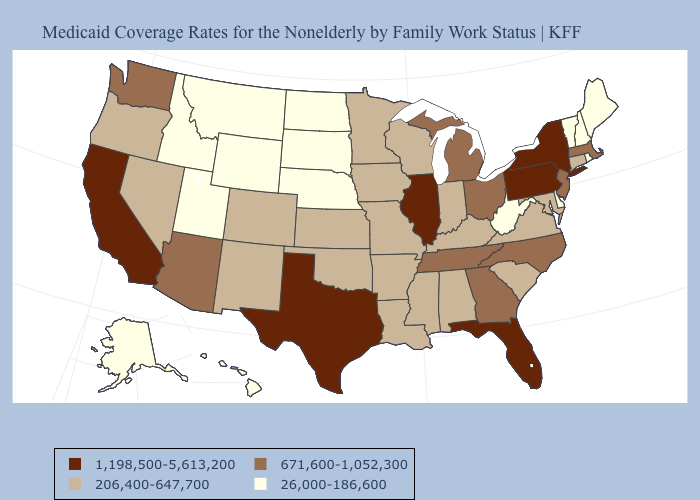What is the highest value in the USA?
Be succinct. 1,198,500-5,613,200. Is the legend a continuous bar?
Be succinct. No. Does Wisconsin have the highest value in the MidWest?
Quick response, please. No. What is the highest value in the MidWest ?
Give a very brief answer. 1,198,500-5,613,200. Among the states that border Wisconsin , which have the lowest value?
Quick response, please. Iowa, Minnesota. Among the states that border California , does Oregon have the lowest value?
Quick response, please. Yes. What is the value of Rhode Island?
Short answer required. 26,000-186,600. Does Kansas have the same value as Iowa?
Give a very brief answer. Yes. Name the states that have a value in the range 1,198,500-5,613,200?
Quick response, please. California, Florida, Illinois, New York, Pennsylvania, Texas. Does North Dakota have the lowest value in the USA?
Give a very brief answer. Yes. Which states have the lowest value in the USA?
Short answer required. Alaska, Delaware, Hawaii, Idaho, Maine, Montana, Nebraska, New Hampshire, North Dakota, Rhode Island, South Dakota, Utah, Vermont, West Virginia, Wyoming. Does Colorado have a higher value than Idaho?
Quick response, please. Yes. Does Wyoming have a higher value than New York?
Quick response, please. No. What is the value of Texas?
Write a very short answer. 1,198,500-5,613,200. Name the states that have a value in the range 206,400-647,700?
Keep it brief. Alabama, Arkansas, Colorado, Connecticut, Indiana, Iowa, Kansas, Kentucky, Louisiana, Maryland, Minnesota, Mississippi, Missouri, Nevada, New Mexico, Oklahoma, Oregon, South Carolina, Virginia, Wisconsin. 